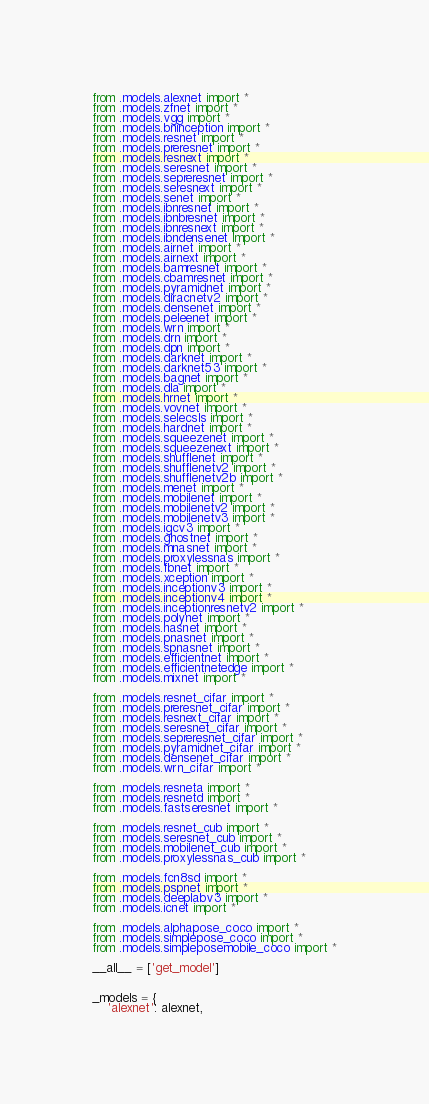<code> <loc_0><loc_0><loc_500><loc_500><_Python_>from .models.alexnet import *
from .models.zfnet import *
from .models.vgg import *
from .models.bninception import *
from .models.resnet import *
from .models.preresnet import *
from .models.resnext import *
from .models.seresnet import *
from .models.sepreresnet import *
from .models.seresnext import *
from .models.senet import *
from .models.ibnresnet import *
from .models.ibnbresnet import *
from .models.ibnresnext import *
from .models.ibndensenet import *
from .models.airnet import *
from .models.airnext import *
from .models.bamresnet import *
from .models.cbamresnet import *
from .models.pyramidnet import *
from .models.diracnetv2 import *
from .models.densenet import *
from .models.peleenet import *
from .models.wrn import *
from .models.drn import *
from .models.dpn import *
from .models.darknet import *
from .models.darknet53 import *
from .models.bagnet import *
from .models.dla import *
from .models.hrnet import *
from .models.vovnet import *
from .models.selecsls import *
from .models.hardnet import *
from .models.squeezenet import *
from .models.squeezenext import *
from .models.shufflenet import *
from .models.shufflenetv2 import *
from .models.shufflenetv2b import *
from .models.menet import *
from .models.mobilenet import *
from .models.mobilenetv2 import *
from .models.mobilenetv3 import *
from .models.igcv3 import *
from .models.ghostnet import *
from .models.mnasnet import *
from .models.proxylessnas import *
from .models.fbnet import *
from .models.xception import *
from .models.inceptionv3 import *
from .models.inceptionv4 import *
from .models.inceptionresnetv2 import *
from .models.polynet import *
from .models.nasnet import *
from .models.pnasnet import *
from .models.spnasnet import *
from .models.efficientnet import *
from .models.efficientnetedge import *
from .models.mixnet import *

from .models.resnet_cifar import *
from .models.preresnet_cifar import *
from .models.resnext_cifar import *
from .models.seresnet_cifar import *
from .models.sepreresnet_cifar import *
from .models.pyramidnet_cifar import *
from .models.densenet_cifar import *
from .models.wrn_cifar import *

from .models.resneta import *
from .models.resnetd import *
from .models.fastseresnet import *

from .models.resnet_cub import *
from .models.seresnet_cub import *
from .models.mobilenet_cub import *
from .models.proxylessnas_cub import *

from .models.fcn8sd import *
from .models.pspnet import *
from .models.deeplabv3 import *
from .models.icnet import *

from .models.alphapose_coco import *
from .models.simplepose_coco import *
from .models.simpleposemobile_coco import *

__all__ = ['get_model']


_models = {
    'alexnet': alexnet,</code> 